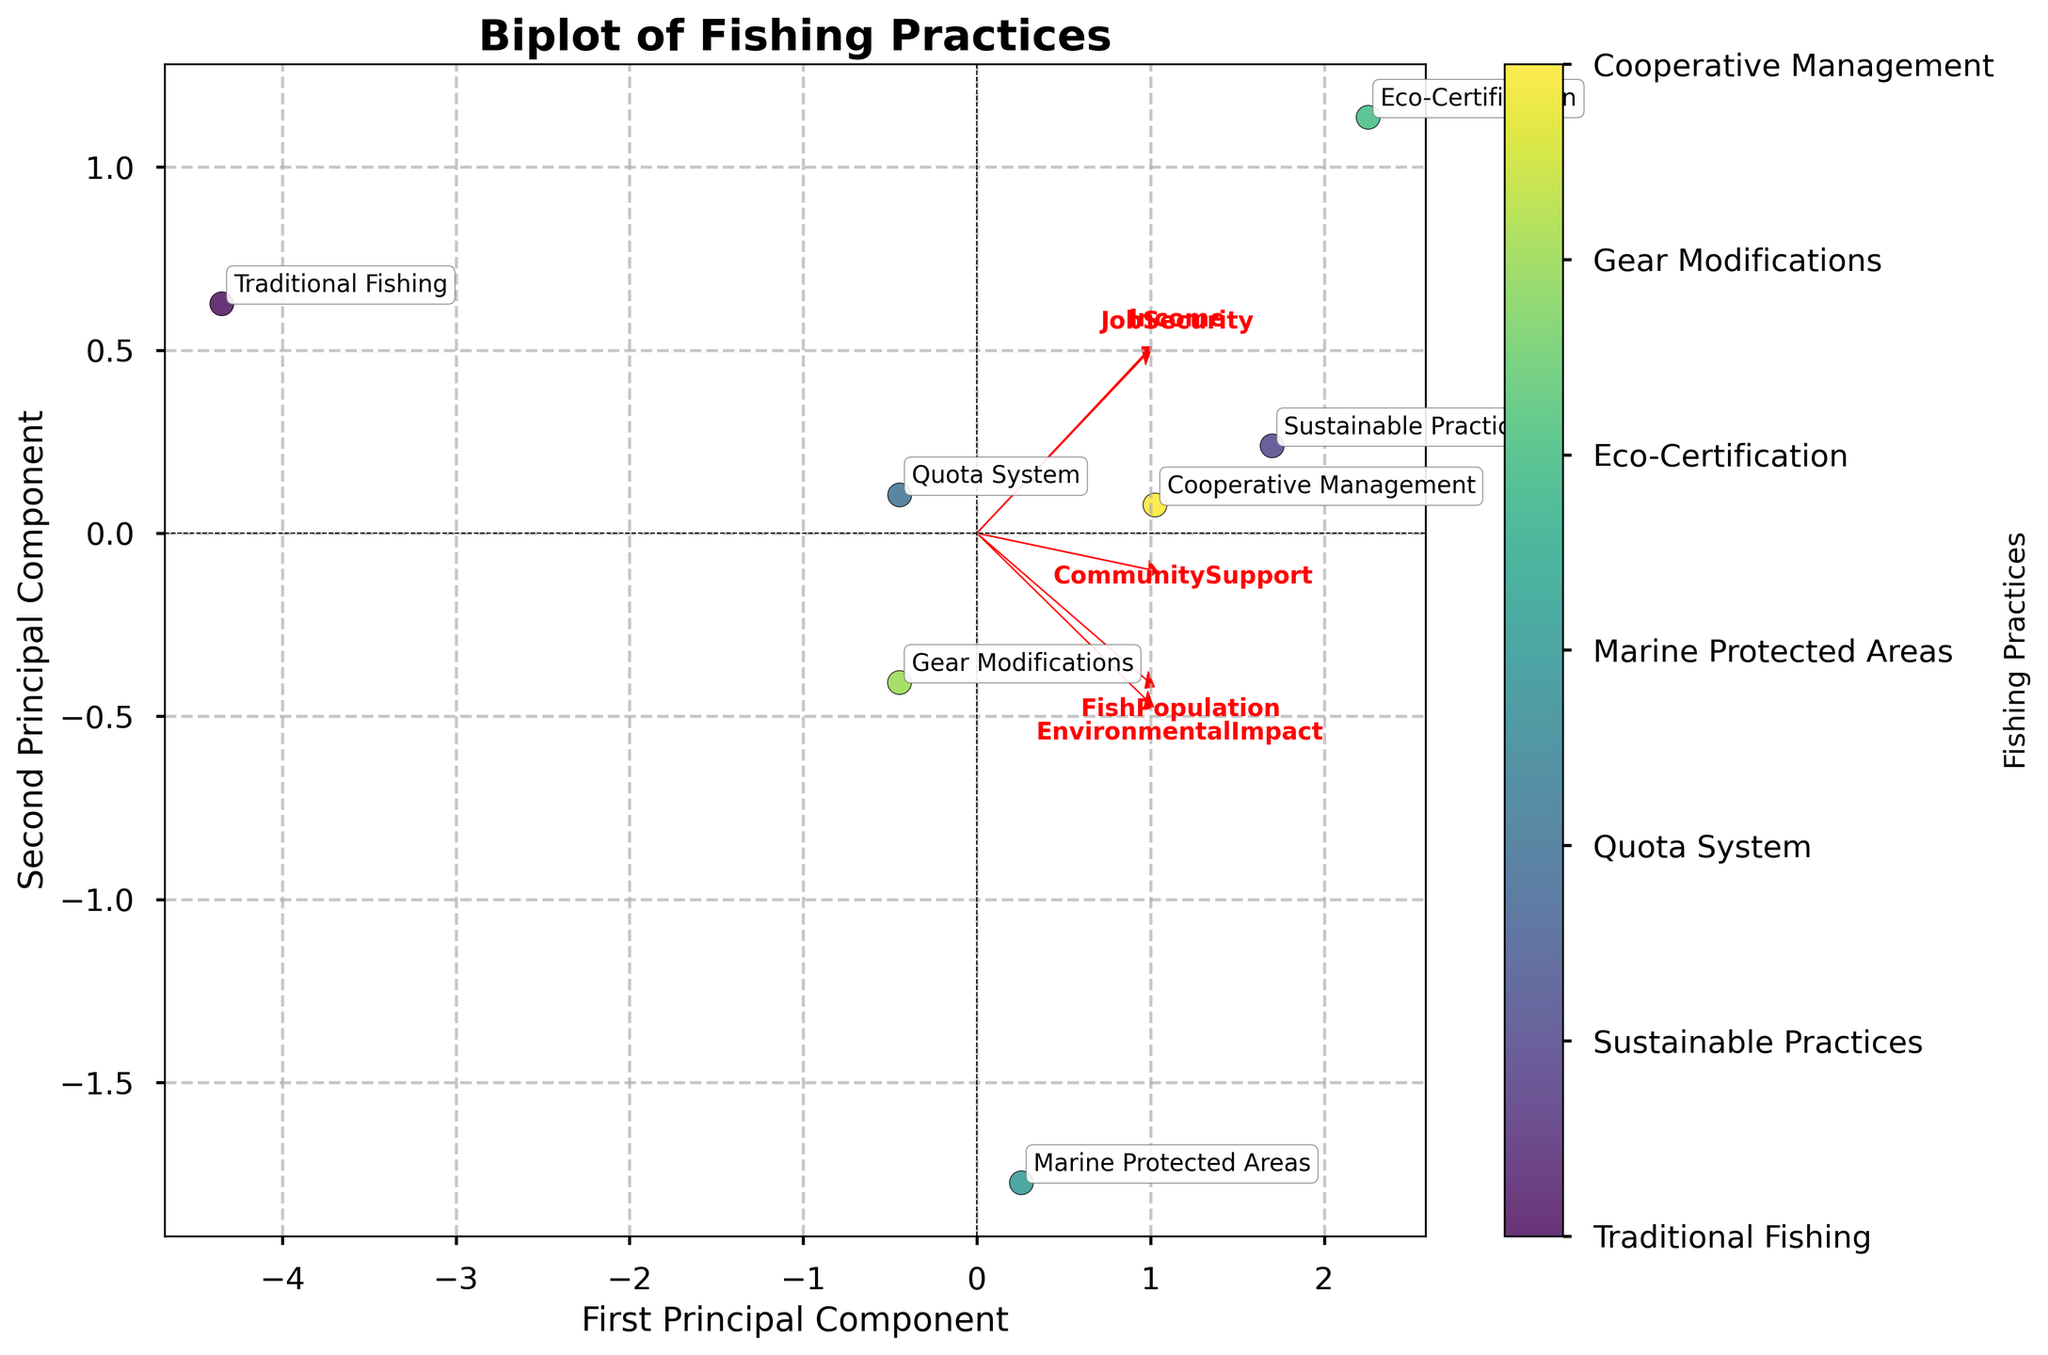What is the title of the plot? The title of the plot is usually displayed at the top of the figure and it provides an overview of what the figure is about. In this case, the title "Biplot of Fishing Practices" indicates the figure visualizes fishing practices.
Answer: Biplot of Fishing Practices What do the axes represent? The axes in the biplot are labeled "First Principal Component" and "Second Principal Component," which are derived from PCA to represent the major directions of variance in the data.
Answer: First Principal Component and Second Principal Component How many different fishing practices are represented in the plot? The colorbar in the biplot indicates different fishing practices. There are 7 labels corresponding to 7 different fishing practices.
Answer: 7 Which fishing practice has the highest values for both principal components? By looking at the plot, identify the data point that is farthest in both the positive direction of the first and second principal components. "Eco-Certification" seems to be located in the top-right quadrant indicating high values in both components.
Answer: Eco-Certification Which variables are strongly associated with the first principal component? The eigenvectors (red arrows) help indicate which variables are strongly associated with each principal component. The longest arrows along the first principal component axis will show strong associations.
Answer: EnvironmentalImpact, CommunitySupport, and FishPopulation How does “Traditional Fishing” compare with “Sustainable Practices” in the biplot? Identify the positions of “Traditional Fishing” and “Sustainable Practices” in the principal component space. By comparing their positions, "Traditional Fishing" is closer to the origin indicating lower values in the principal components compared to “Sustainable Practices.”
Answer: Sustainable Practices have higher values in the components Which fishing practice is closest to the origin in the biplot? The data point nearest to the origin (0,0) represents the fishing practice with the least variance in the principal component space. "Traditional Fishing" appears closest to the origin.
Answer: Traditional Fishing What does the length and direction of the "Income" arrow indicate about its relationship with the principal components? The "Income" arrow's length and direction indicate how much it contributes to the principal components. If it’s long and points primarily along the first component axis, it means "Income" has a strong positive relationship with that component.
Answer: Strong positive relationship with the first component What could be the environmental impact of "Quota System" relative to "Marine Protected Areas"? Determine the positions of "Quota System" and "Marine Protected Areas" and the direction of the "Environmental Impact" arrow. "Marine Protected Areas" is positioned closer to the direction of the environmental impact arrow, suggesting a greater impact relative to the "Quota System."
Answer: Marine Protected Areas have a greater environmental impact than Quota System Which variable contributes the least to the second principal component based on the direction of the arrows? Check the orientation of the red arrows in relation to the second principal component. The arrow with the smallest projection on this axis shows the least contribution.
Answer: Income 